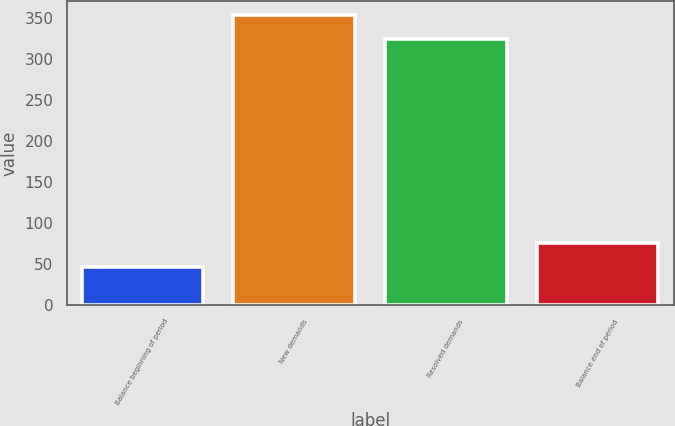Convert chart. <chart><loc_0><loc_0><loc_500><loc_500><bar_chart><fcel>Balance beginning of period<fcel>New demands<fcel>Resolved demands<fcel>Balance end of period<nl><fcel>47<fcel>353.6<fcel>325<fcel>75.6<nl></chart> 